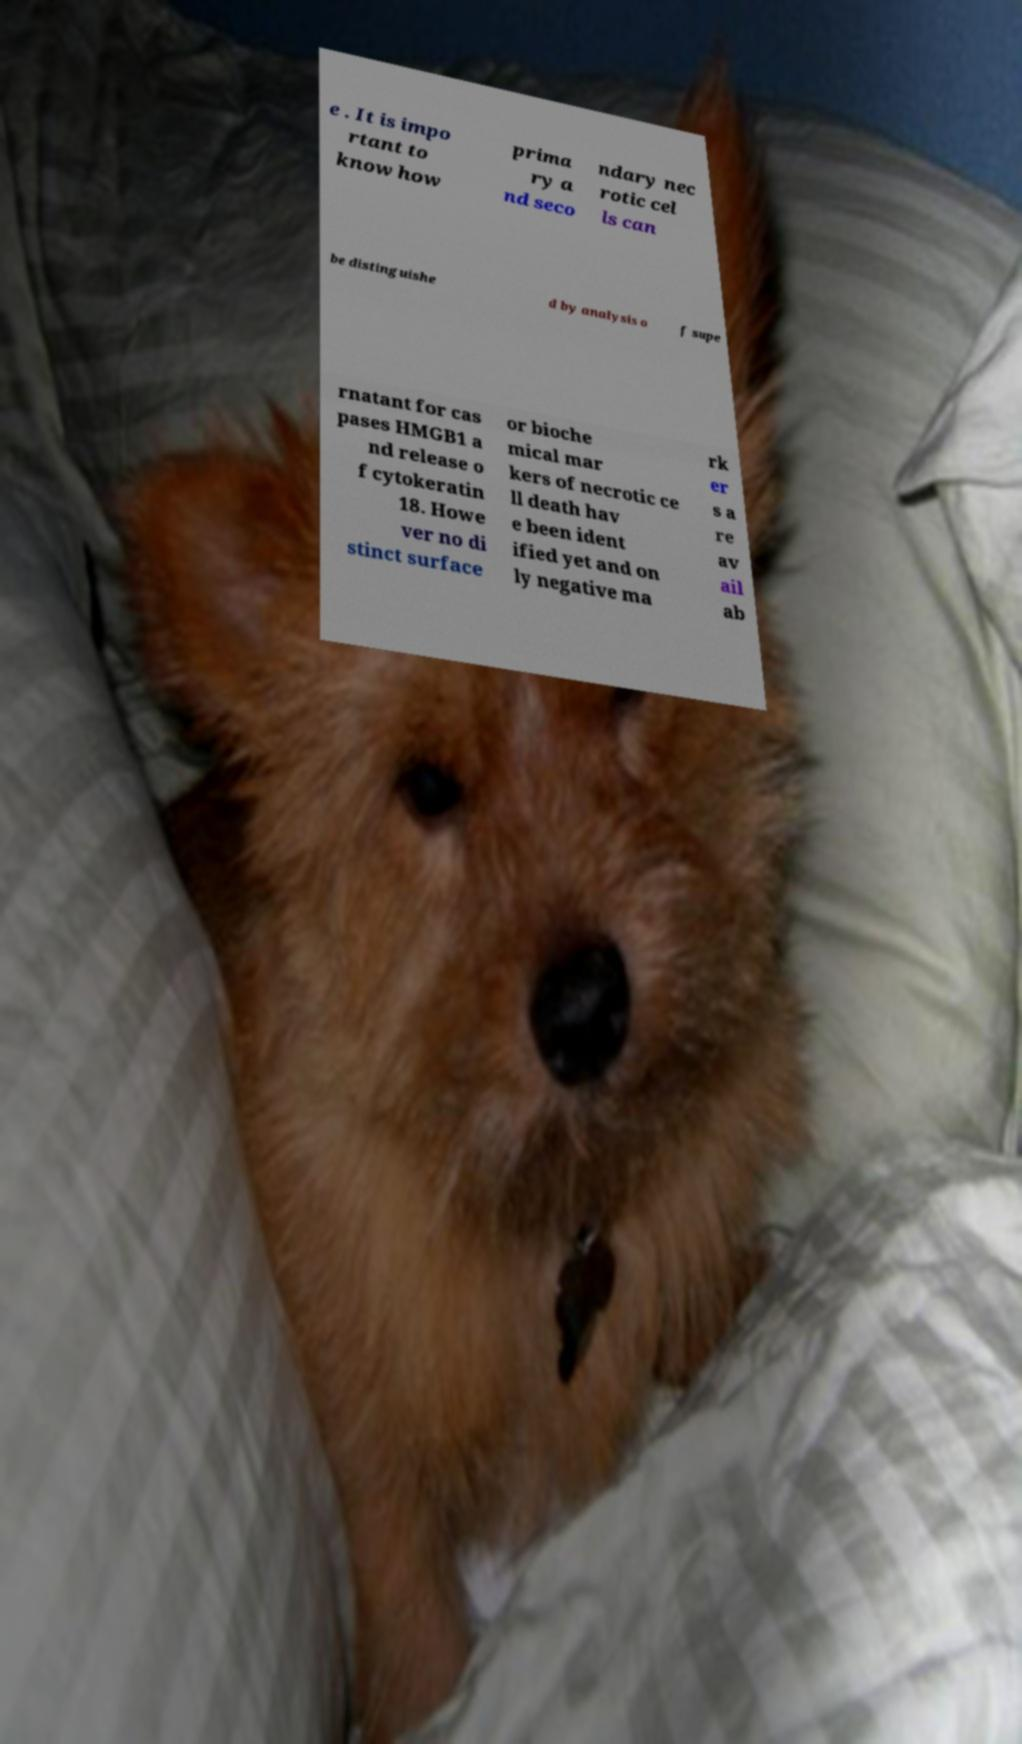Can you read and provide the text displayed in the image?This photo seems to have some interesting text. Can you extract and type it out for me? e . It is impo rtant to know how prima ry a nd seco ndary nec rotic cel ls can be distinguishe d by analysis o f supe rnatant for cas pases HMGB1 a nd release o f cytokeratin 18. Howe ver no di stinct surface or bioche mical mar kers of necrotic ce ll death hav e been ident ified yet and on ly negative ma rk er s a re av ail ab 